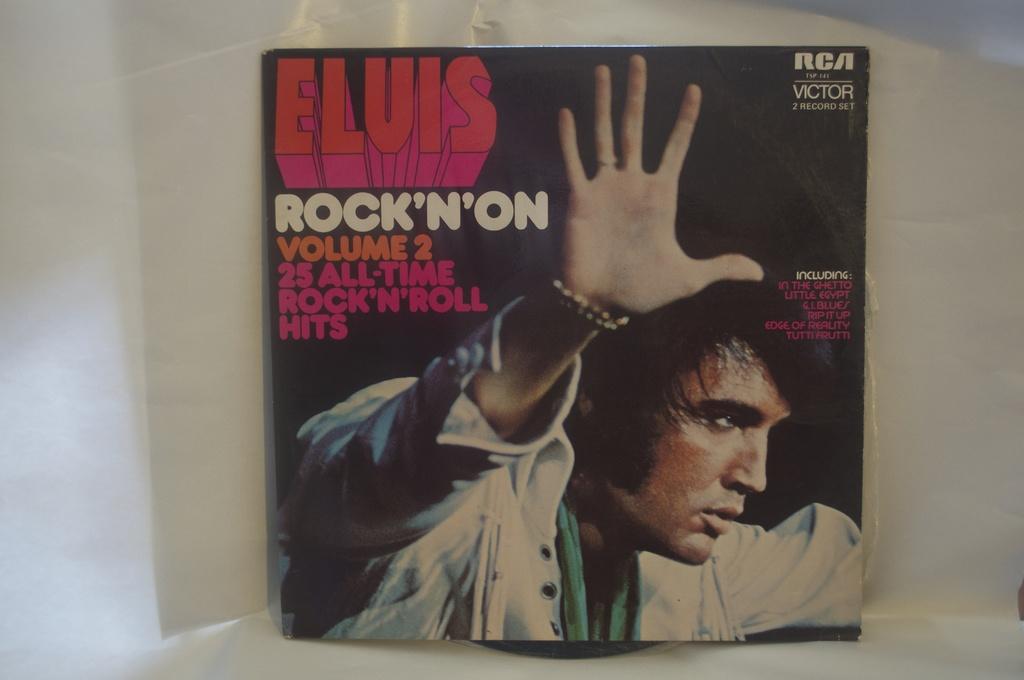Who is the artist of this album?
Your answer should be very brief. Elvis. What record label is this release on?
Keep it short and to the point. Rca. 